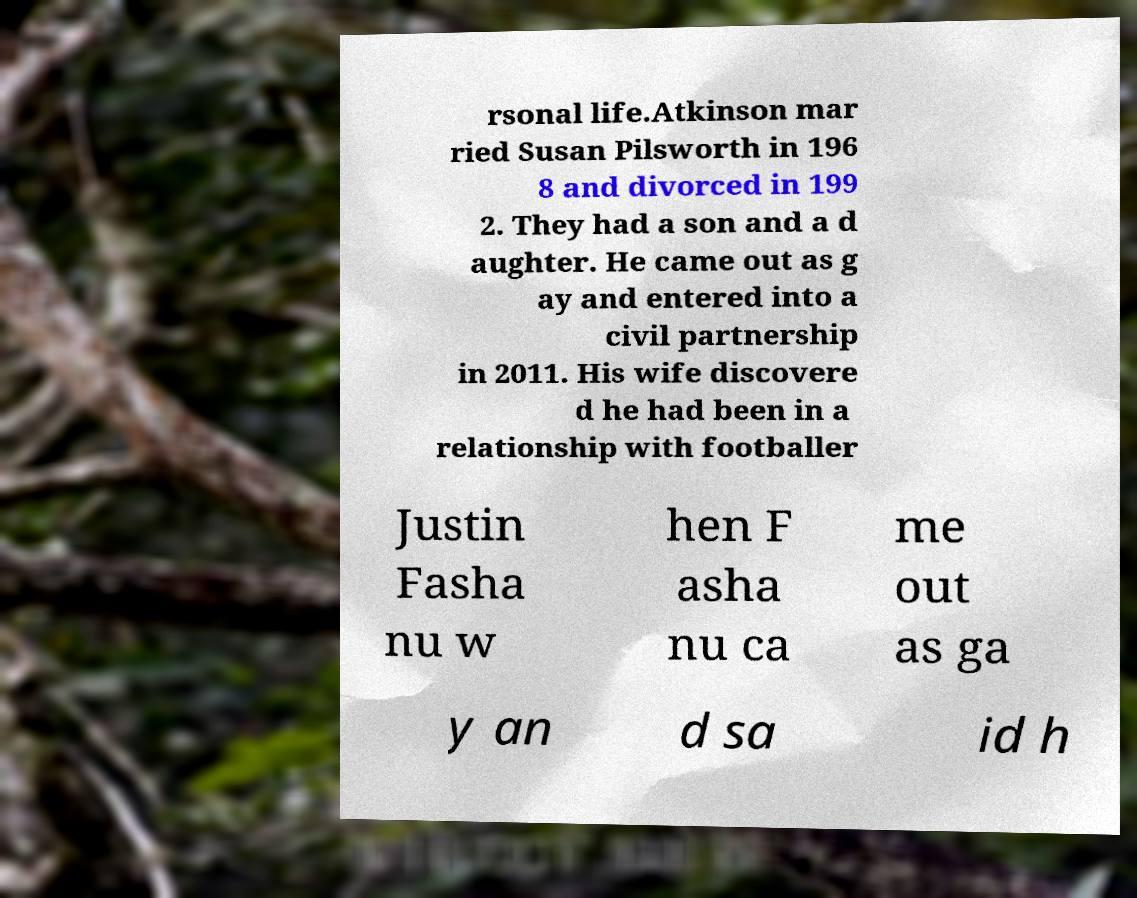Please read and relay the text visible in this image. What does it say? rsonal life.Atkinson mar ried Susan Pilsworth in 196 8 and divorced in 199 2. They had a son and a d aughter. He came out as g ay and entered into a civil partnership in 2011. His wife discovere d he had been in a relationship with footballer Justin Fasha nu w hen F asha nu ca me out as ga y an d sa id h 